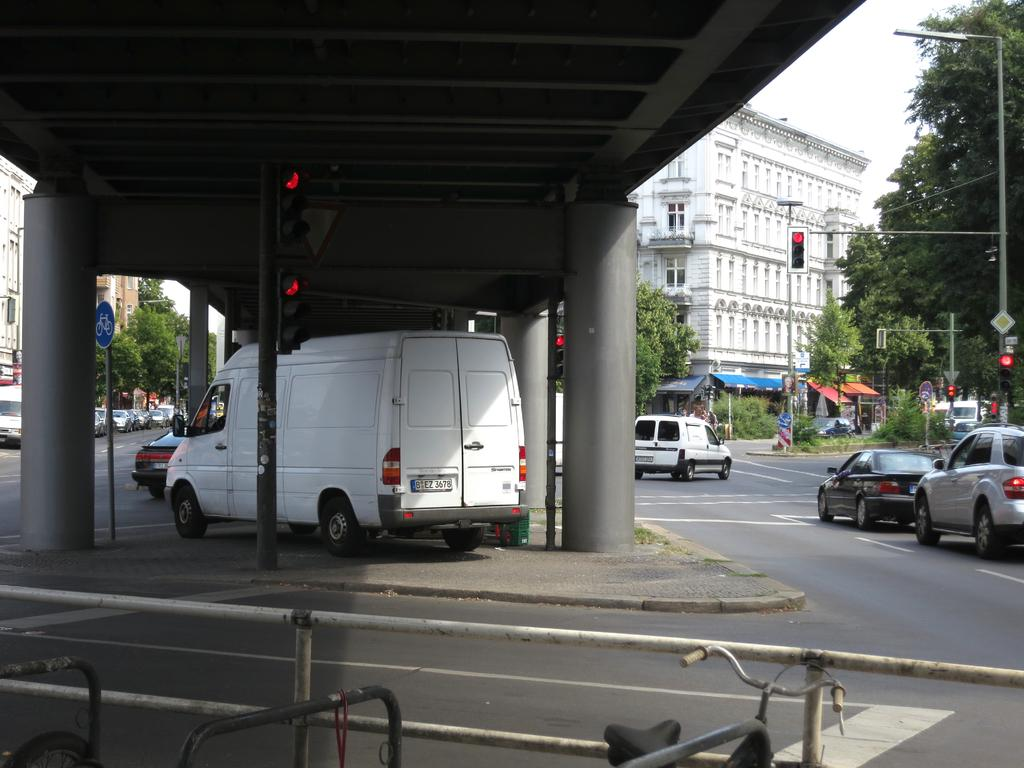What types of objects can be seen in the image? There are vehicles, trees, buildings, poles, signboards, lights, and windows visible in the image. Where are some of the vehicles located in the image? Some vehicles are under a bridge in the image. What can be seen above the vehicles and bridge? The sky is visible in the image. Can you see a monkey climbing on the trees in the image? There is no monkey present in the image; only vehicles, trees, buildings, poles, signboards, lights, and windows are visible. What does the earth look like in the image? The image does not show the earth as a whole; it only shows a portion of the ground and the objects mentioned in the facts. 